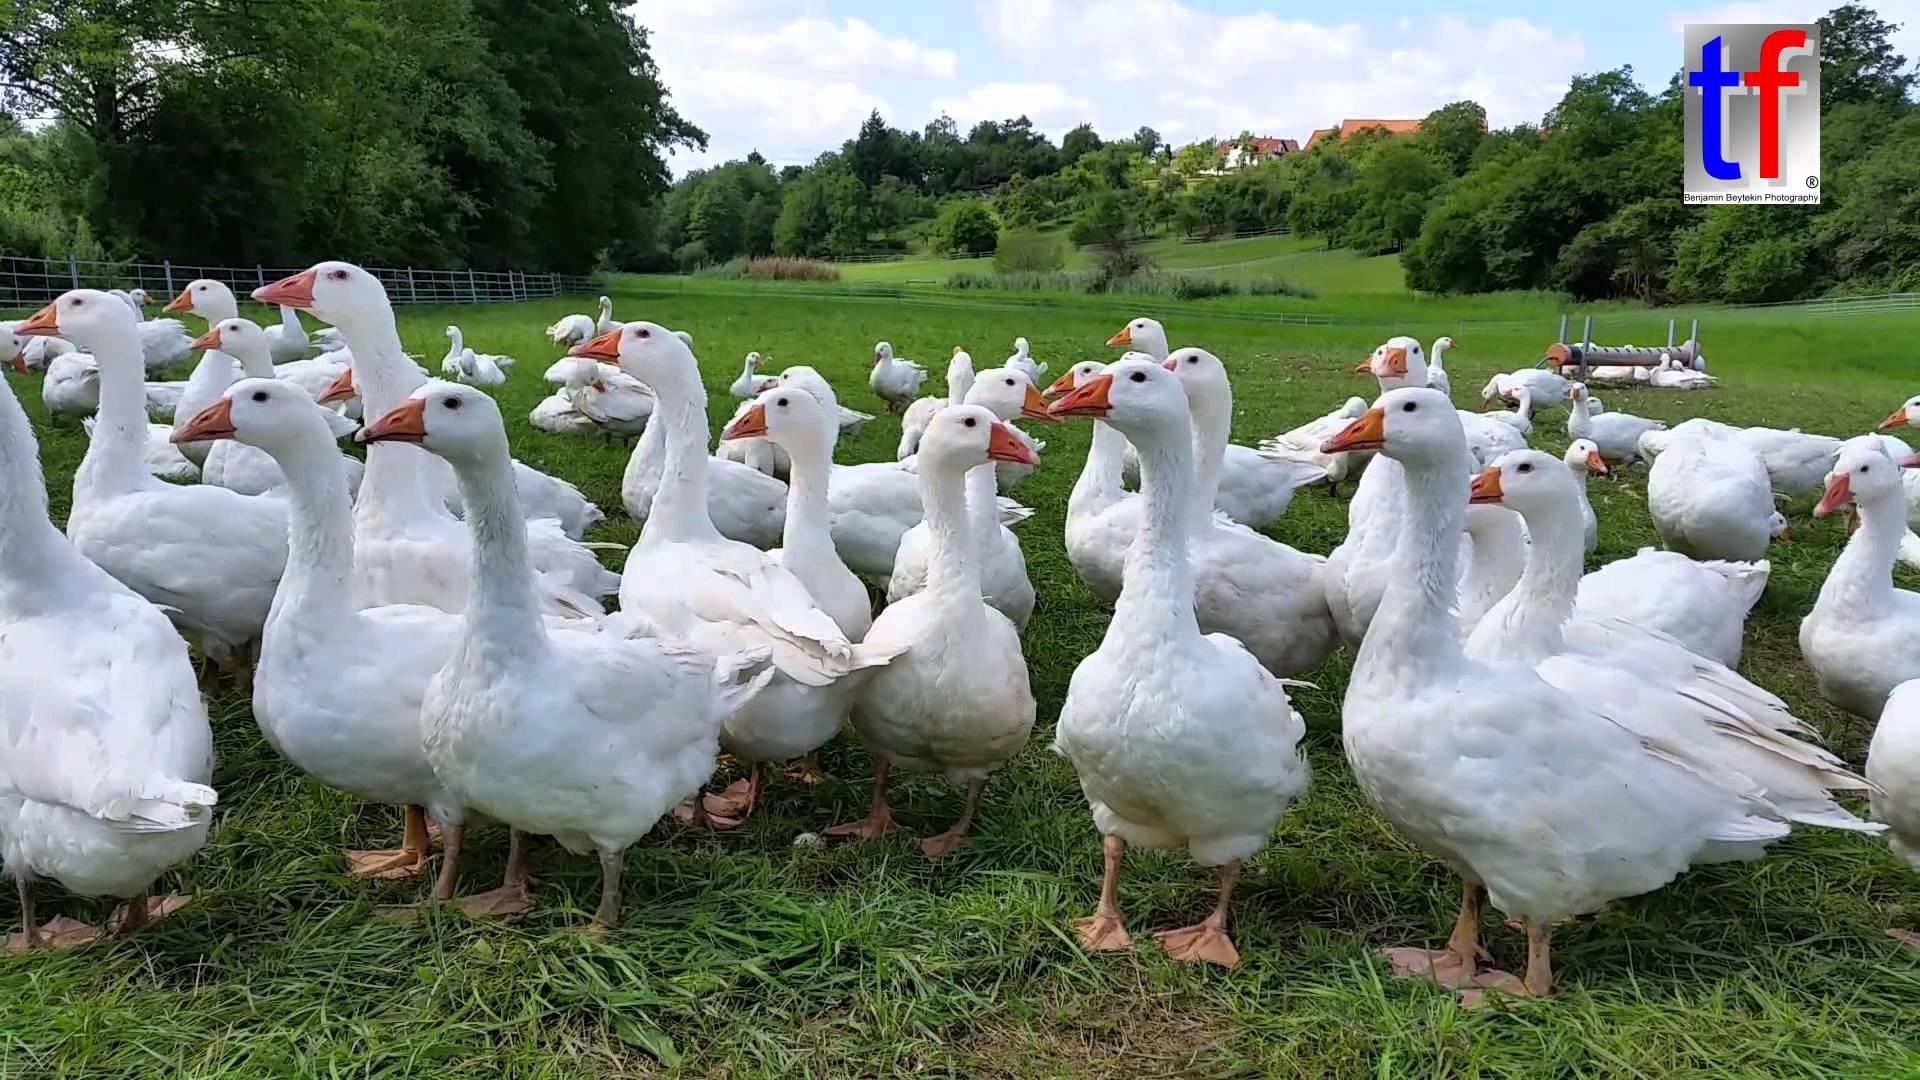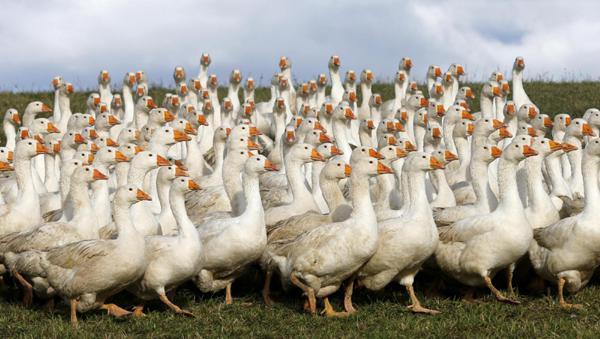The first image is the image on the left, the second image is the image on the right. Evaluate the accuracy of this statement regarding the images: "At least one image shows no less than 20 white fowl.". Is it true? Answer yes or no. Yes. The first image is the image on the left, the second image is the image on the right. For the images shown, is this caption "One of the images shows exactly 6 geese." true? Answer yes or no. No. 